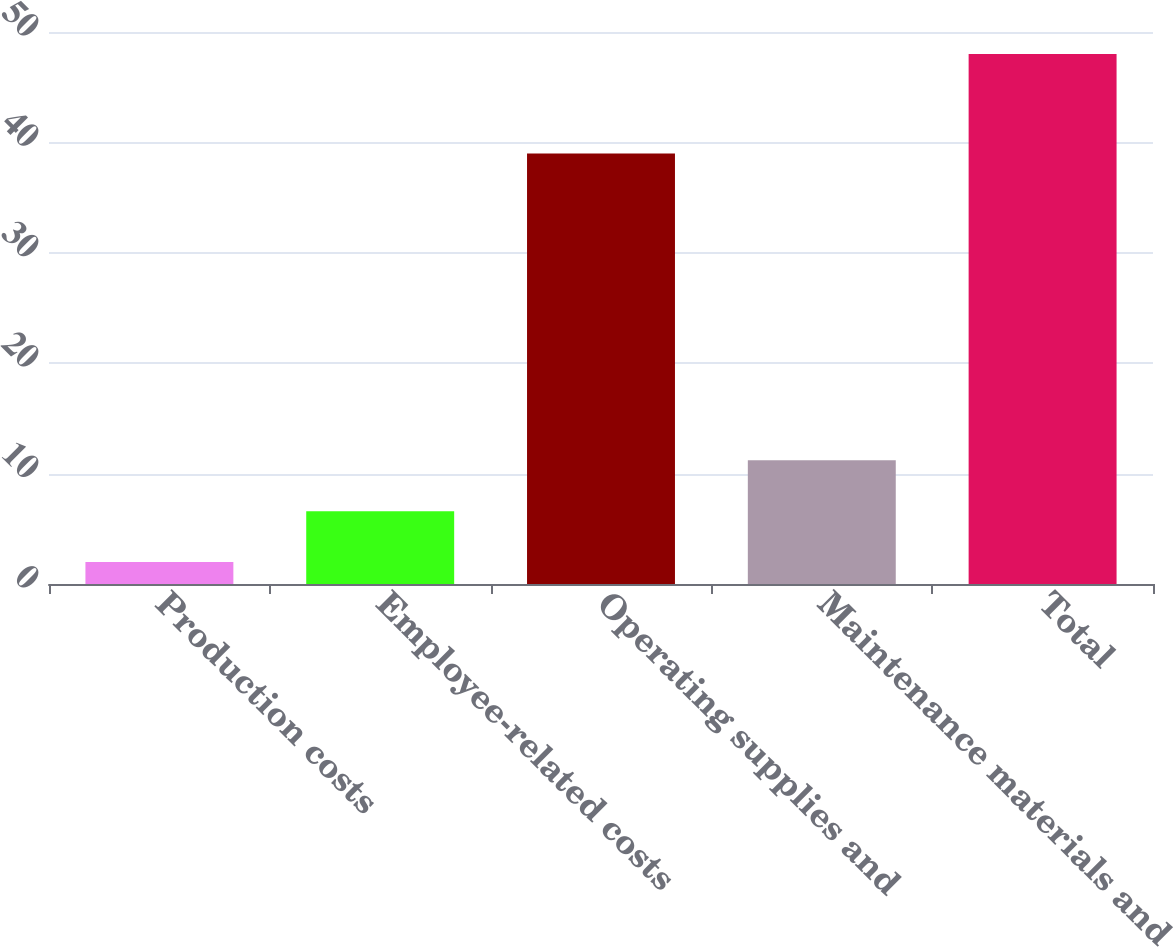<chart> <loc_0><loc_0><loc_500><loc_500><bar_chart><fcel>Production costs<fcel>Employee-related costs<fcel>Operating supplies and<fcel>Maintenance materials and<fcel>Total<nl><fcel>2<fcel>6.6<fcel>39<fcel>11.2<fcel>48<nl></chart> 